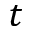<formula> <loc_0><loc_0><loc_500><loc_500>t</formula> 